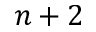Convert formula to latex. <formula><loc_0><loc_0><loc_500><loc_500>n + 2</formula> 